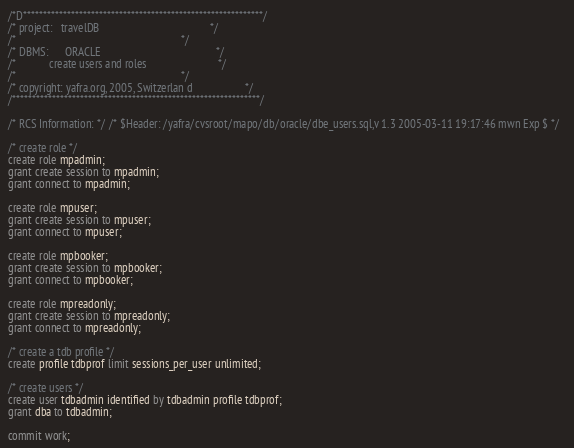Convert code to text. <code><loc_0><loc_0><loc_500><loc_500><_SQL_>/*D************************************************************/ 
/* project:   travelDB                                        */ 
/*                                                            */ 
/* DBMS:      ORACLE                                          */ 
/*            create users and roles                          */ 
/*                                                            */ 
/* copyright: yafra.org, 2005, Switzerlan d                   */ 
/**************************************************************/ 
 
/* RCS Information: */ /* $Header: /yafra/cvsroot/mapo/db/oracle/dbe_users.sql,v 1.3 2005-03-11 19:17:46 mwn Exp $ */  
 
/* create role */ 
create role mpadmin; 
grant create session to mpadmin; 
grant connect to mpadmin; 

create role mpuser; 
grant create session to mpuser; 
grant connect to mpuser; 

create role mpbooker; 
grant create session to mpbooker; 
grant connect to mpbooker; 

create role mpreadonly; 
grant create session to mpreadonly; 
grant connect to mpreadonly;  

/* create a tdb profile */ 
create profile tdbprof limit sessions_per_user unlimited;  

/* create users */ 
create user tdbadmin identified by tdbadmin profile tdbprof;
grant dba to tdbadmin;

commit work;</code> 